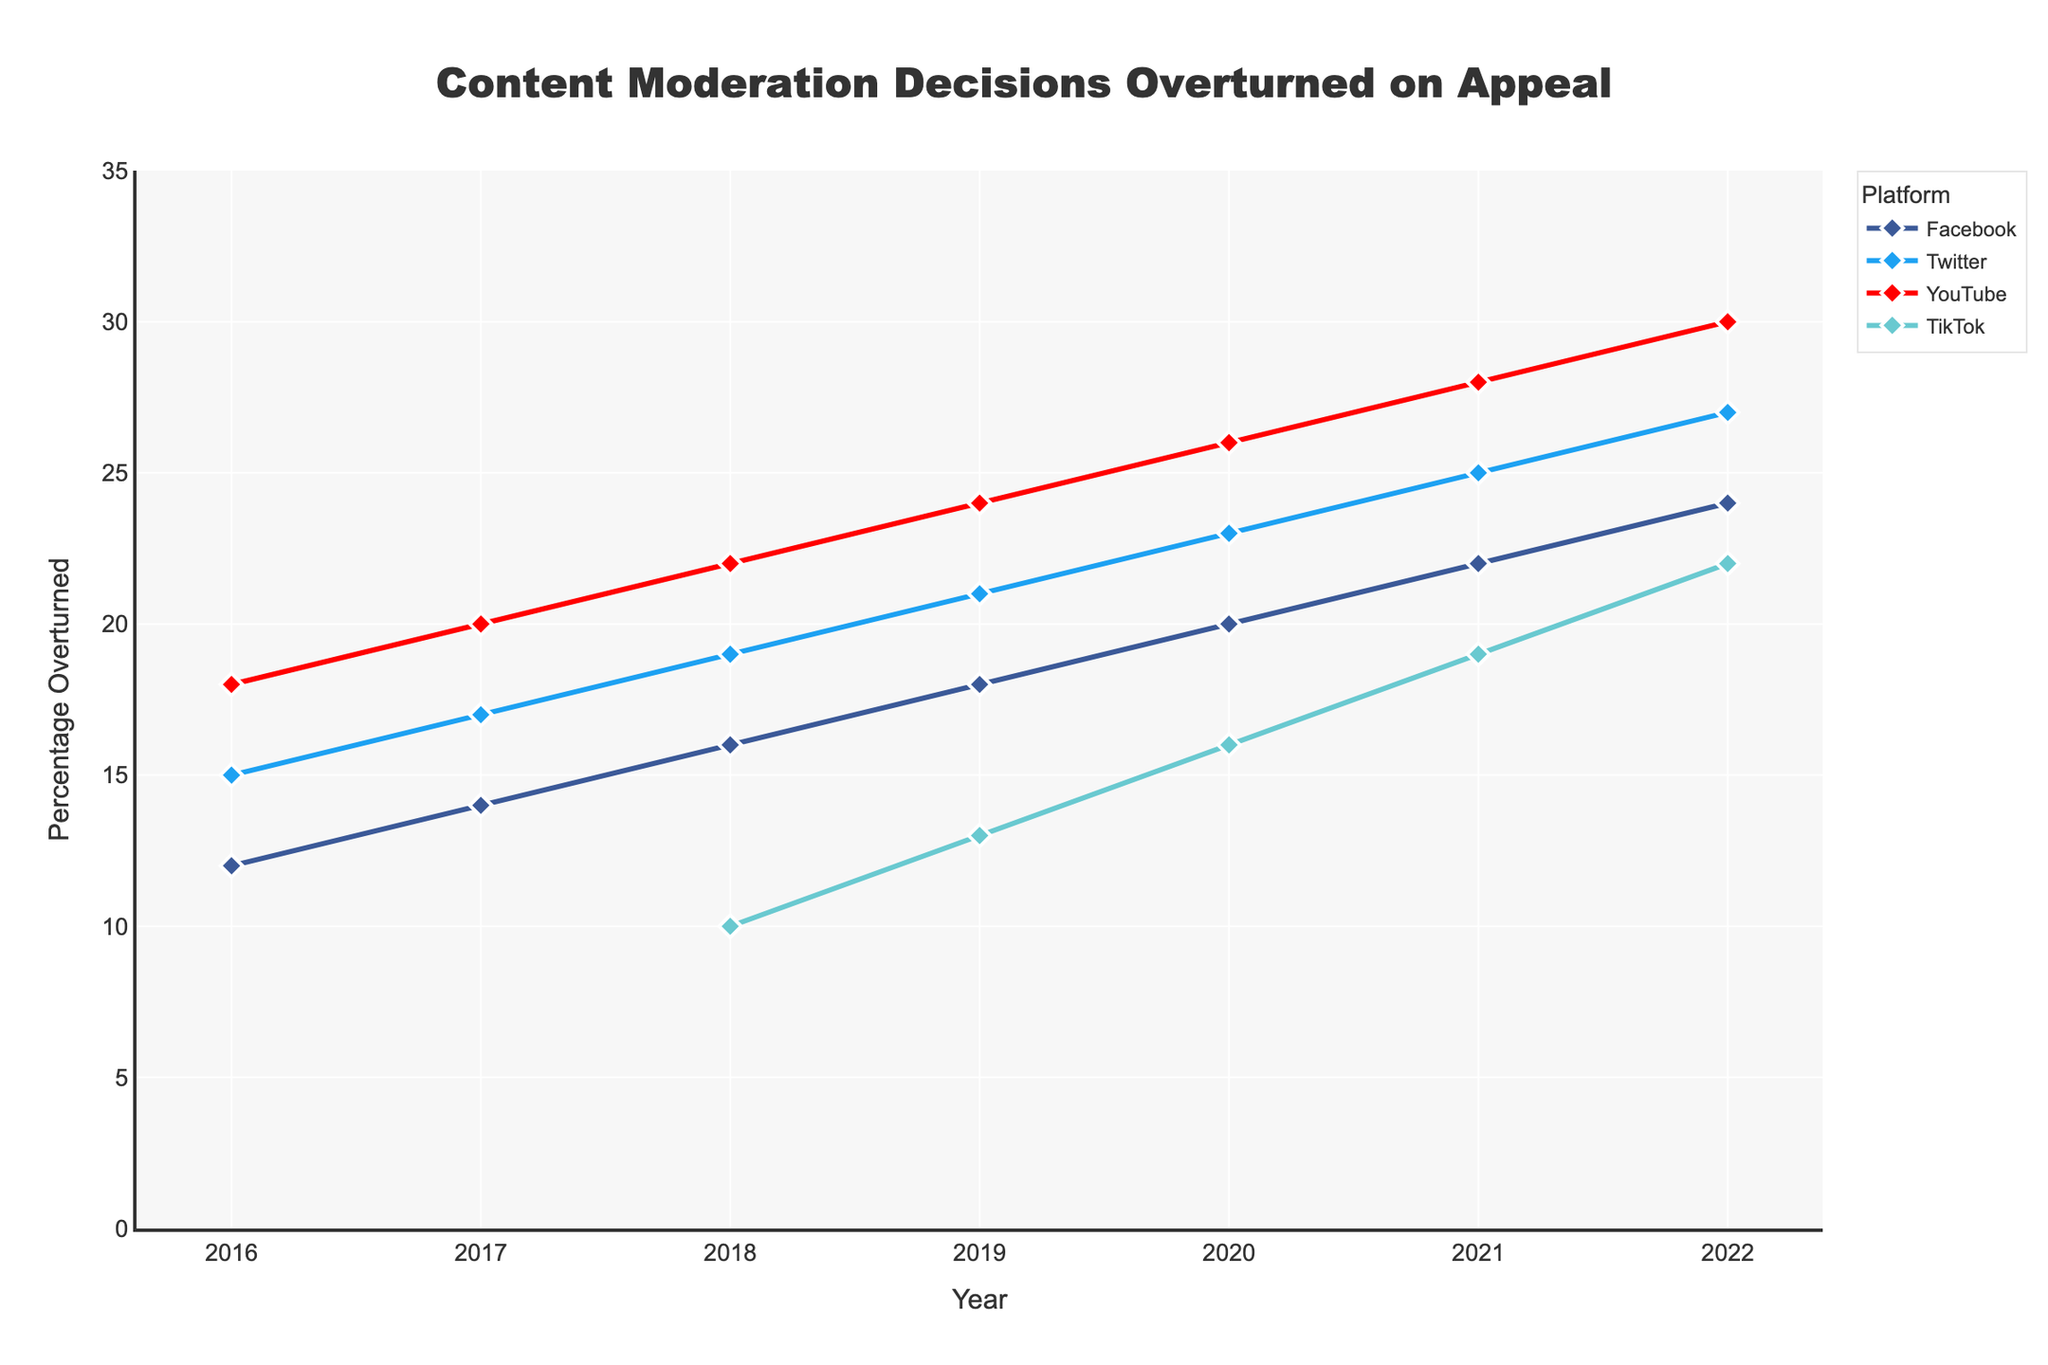Which platform had the highest percentage of content moderation decisions overturned in 2022? From the chart, look at the lines representing each platform in 2022 and identify the one that reaches the highest value.
Answer: YouTube How did the percentage of content moderation decisions overturned for Twitter change from 2016 to 2022? Compare the percentage for Twitter at 2016 and then look at the percentage in 2022. Subtract the 2016 value from the 2022 value to find the change.
Answer: Increased by 12% (from 15% to 27%) Which platforms have continuously increased their percentage of overturned content moderation decisions from 2016 to 2022? Scan each platform's line from 2016 to 2022 and confirm if each year the percentage is higher than the previous year.
Answer: All four (Facebook, Twitter, YouTube, TikTok) What is the average percentage of content moderation decisions overturned for Facebook across the years shown? Sum Facebook's percentages for each year and divide by the number of years (7 years). (12+14+16+18+20+22+24)/7 = 126/7
Answer: 18% Between Facebook and TikTok, which platform showed a faster increase in the percentage of content moderation decisions overturned between 2018 and 2022? Calculate the difference for both platforms between 2018 and 2022, then compare the increases. Facebook increase: 24-16 = 8, TikTok increase: 22-10 = 12
Answer: TikTok In which year did YouTube start having a higher percentage of overturned content moderation decisions compared to Twitter? Compare YouTube and Twitter lines year by year until YouTube surpasses Twitter.
Answer: 2018 How do the percentage increases between 2020 and 2021 for Facebook and YouTube compare? Calculate the percentage increase for both platforms between 2020 and 2021, then compare them. Facebook increase: 22-20 = 2, YouTube increase: 28-26 = 2
Answer: Equal Which year had the largest combined percentage of overturned content moderation decisions across all platforms available at that time? Sum the percentages for all available platforms for each year and find the highest total. For example: for 2022, sum 24 (Facebook) + 27 (Twitter) + 30 (YouTube) + 22 (TikTok)
Answer: 2022 (24+27+30+22 = 103) What is the difference in the percentage of overturned content moderation decisions between YouTube and Facebook in 2021? Look at the respective percentages for YouTube and Facebook in 2021 and subtract the Facebook percentage from the YouTube percentage. 28 - 22
Answer: 6% What is the trend of the percentage of overturned content moderation decisions for TikTok from 2018 to 2022 in terms of increase per year? Look at the percentages for TikTok from 2018 to 2022 and find the average increasing rate per year: (2022-2018):(22-10)/4
Answer: 3% per year 